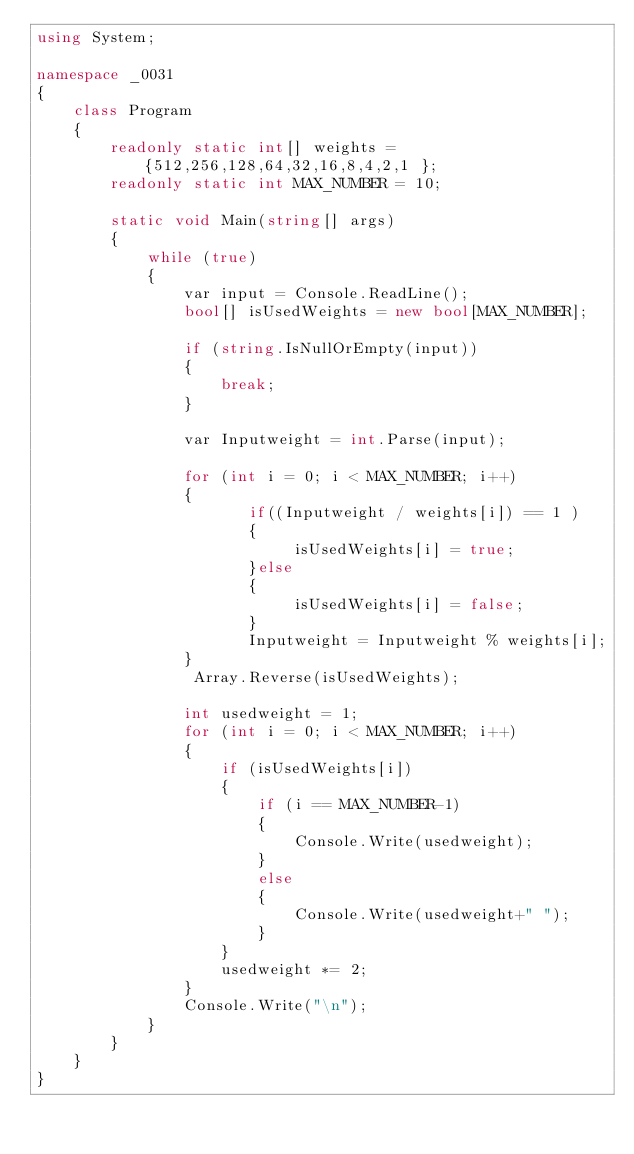Convert code to text. <code><loc_0><loc_0><loc_500><loc_500><_C#_>using System;

namespace _0031
{
    class Program
    {
        readonly static int[] weights = {512,256,128,64,32,16,8,4,2,1 };
        readonly static int MAX_NUMBER = 10;

        static void Main(string[] args)
        {
            while (true)
            {
                var input = Console.ReadLine();
                bool[] isUsedWeights = new bool[MAX_NUMBER];

                if (string.IsNullOrEmpty(input))
                {
                    break;
                }

                var Inputweight = int.Parse(input);

                for (int i = 0; i < MAX_NUMBER; i++)
                {
                       if((Inputweight / weights[i]) == 1 )
                       {
                            isUsedWeights[i] = true;
                       }else
                       {
                            isUsedWeights[i] = false;
                       }
                       Inputweight = Inputweight % weights[i];
                }
                 Array.Reverse(isUsedWeights);

                int usedweight = 1;
                for (int i = 0; i < MAX_NUMBER; i++)
                {
                    if (isUsedWeights[i])
                    {
                        if (i == MAX_NUMBER-1)
                        {
                            Console.Write(usedweight);
                        }
                        else 
                        {
                            Console.Write(usedweight+" ");
                        }
                    }
                    usedweight *= 2;
                }
                Console.Write("\n");
            }
        }
    }
}</code> 